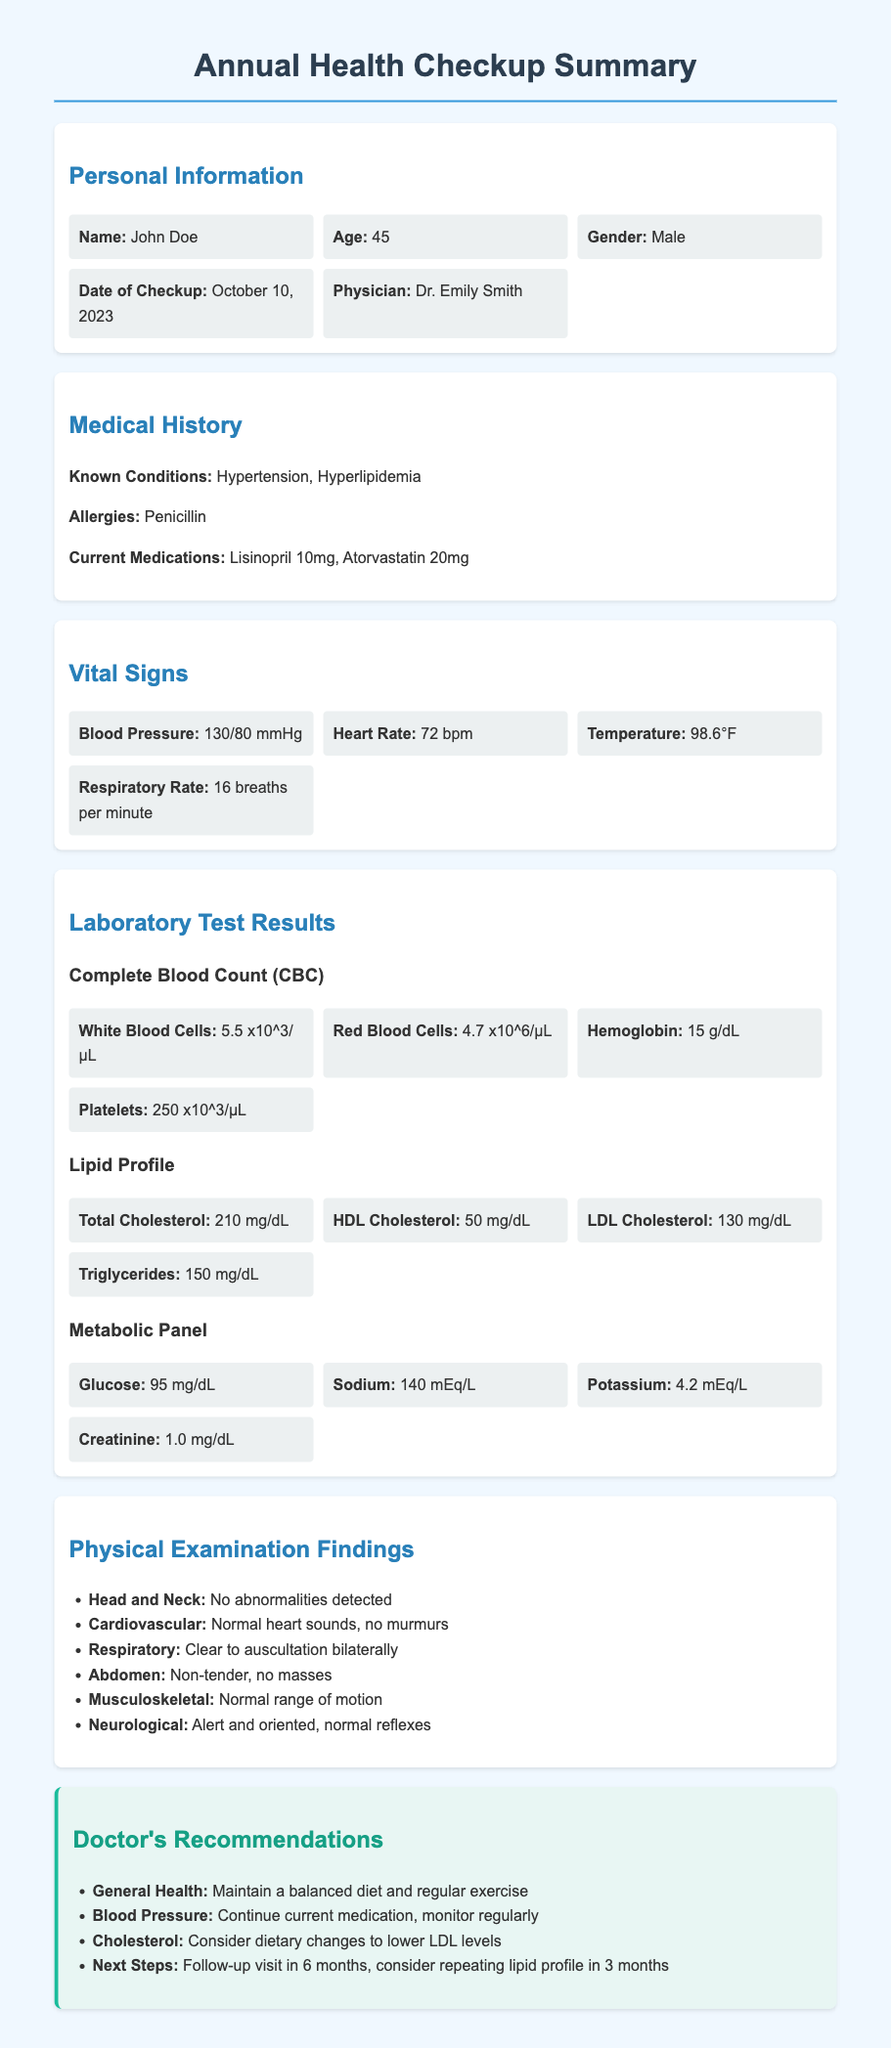What is the name of the patient? The document clearly states the name of the patient in the personal information section.
Answer: John Doe What is the age of the patient? The age is provided alongside the name in the personal information section.
Answer: 45 What is the specific date of the checkup? The date of the checkup is listed in the personal information section.
Answer: October 10, 2023 What medication is the patient currently taking? The current medications are listed under the medical history section.
Answer: Lisinopril 10mg, Atorvastatin 20mg What is the patient's blood pressure? The vital signs section provides the patient's blood pressure reading specifically.
Answer: 130/80 mmHg What recommendation is given for blood pressure? The doctor's recommendations section includes specific advice regarding blood pressure.
Answer: Continue current medication, monitor regularly How is the cardiovascular examination finding described? The physical examination findings section contains descriptions of the cardiovascular health assessment.
Answer: Normal heart sounds, no murmurs What is the patient's total cholesterol level? The lipid profile section mentions the total cholesterol measurement.
Answer: 210 mg/dL When is the next follow-up visit recommended? The recommendations section states when the next visit should occur.
Answer: In 6 months 